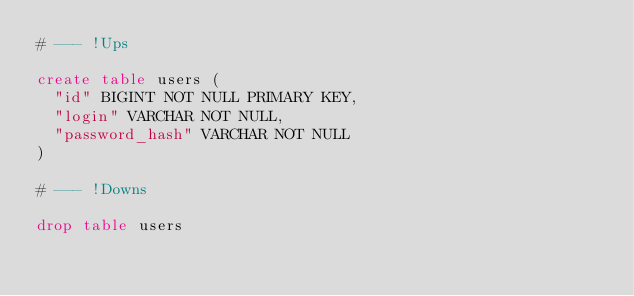Convert code to text. <code><loc_0><loc_0><loc_500><loc_500><_SQL_># --- !Ups

create table users (
  "id" BIGINT NOT NULL PRIMARY KEY,
  "login" VARCHAR NOT NULL,
  "password_hash" VARCHAR NOT NULL
)

# --- !Downs

drop table users

</code> 